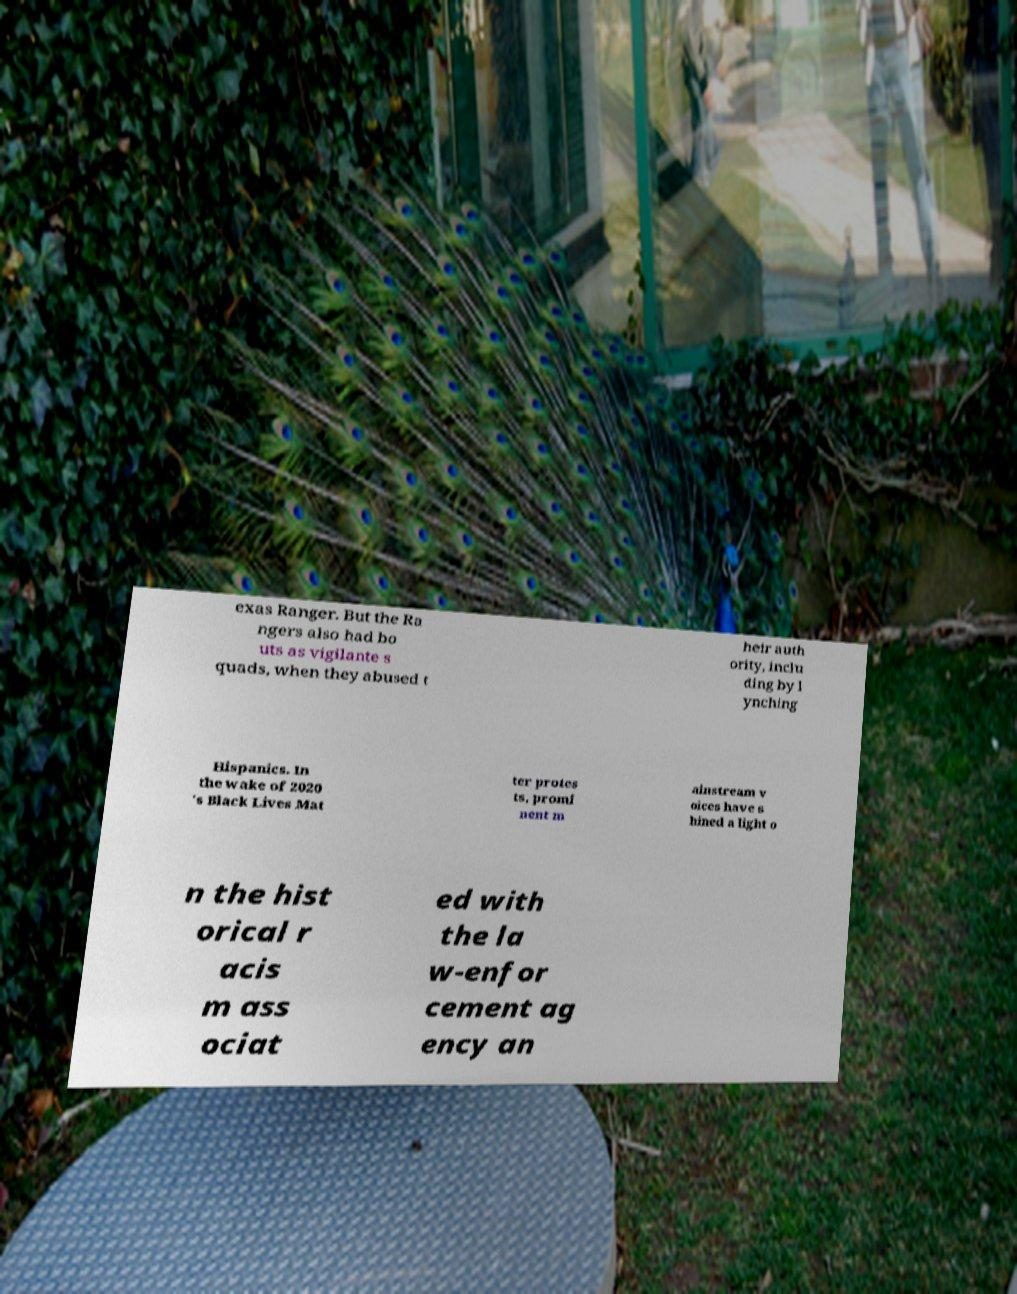For documentation purposes, I need the text within this image transcribed. Could you provide that? exas Ranger. But the Ra ngers also had bo uts as vigilante s quads, when they abused t heir auth ority, inclu ding by l ynching Hispanics. In the wake of 2020 's Black Lives Mat ter protes ts, promi nent m ainstream v oices have s hined a light o n the hist orical r acis m ass ociat ed with the la w-enfor cement ag ency an 